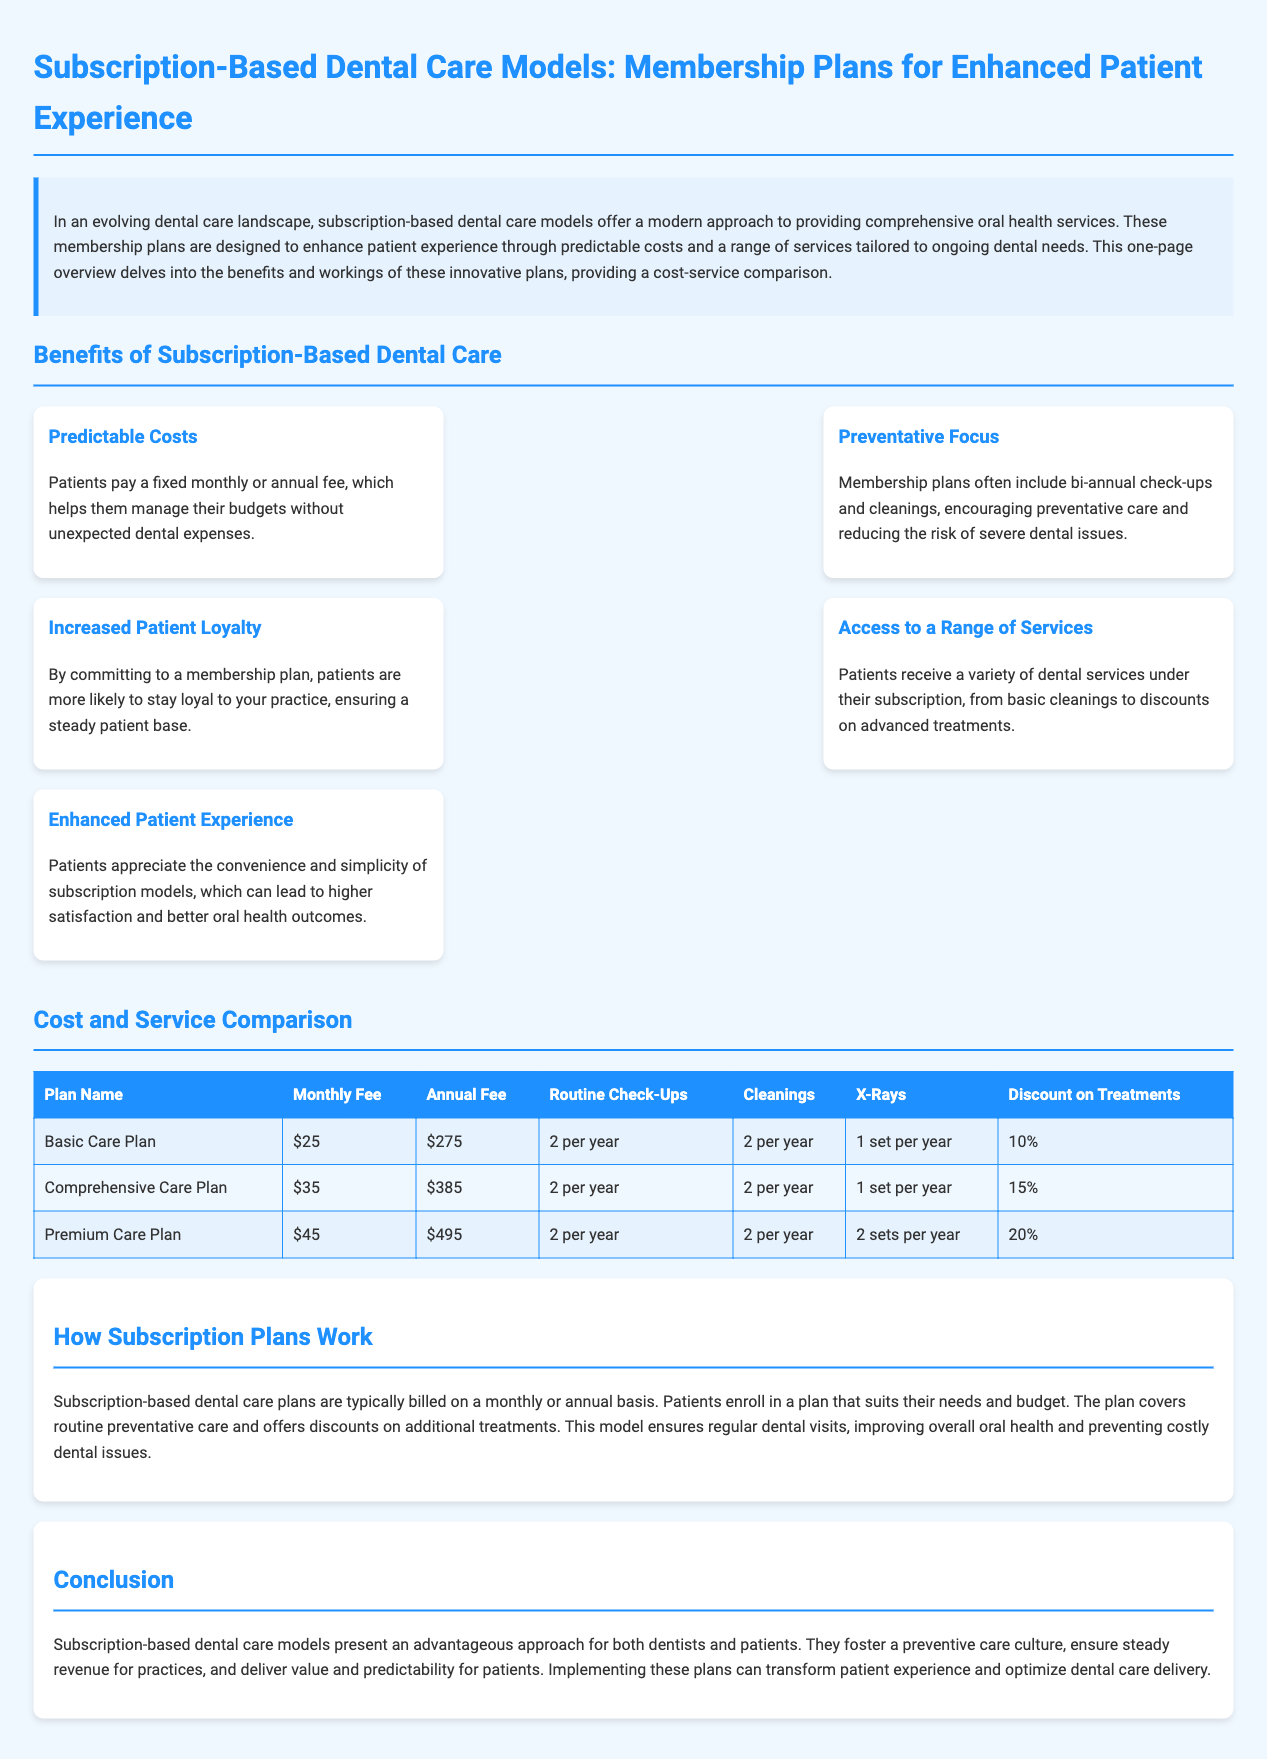What are the two types of payment for subscription plans? The document mentions that subscription plans can be billed on a monthly or annual basis.
Answer: monthly or annual What is included in the Basic Care Plan? The Basic Care Plan includes routine check-ups, cleanings, x-rays, and a discount on treatments as stated in the comparison table.
Answer: 2 check-ups, 2 cleanings, 1 x-ray, 10% discount How much is the monthly fee for the Comprehensive Care Plan? The monthly fee for the Comprehensive Care Plan is directly stated in the comparison table.
Answer: $35 What is the main advantage for patients in subscription models? The document emphasizes that subscription models result in predictable costs, enhancing financial planning for patients.
Answer: predictable costs What is the discount on treatments for the Premium Care Plan? The document specifies the discount on treatments offered under the Premium Care Plan in the comparison table.
Answer: 20% How do membership plans impact patient loyalty? The document states that patients are more likely to stay loyal to practices offering membership plans.
Answer: Increased patient loyalty What is the purpose of subscription-based dental care models? The purpose of subscription-based models is to provide comprehensive oral health services while improving patient experience.
Answer: comprehensive oral health services What type of care do membership plans encourage? The document highlights that membership plans often focus on preventative care, leading to better health outcomes.
Answer: preventative care 